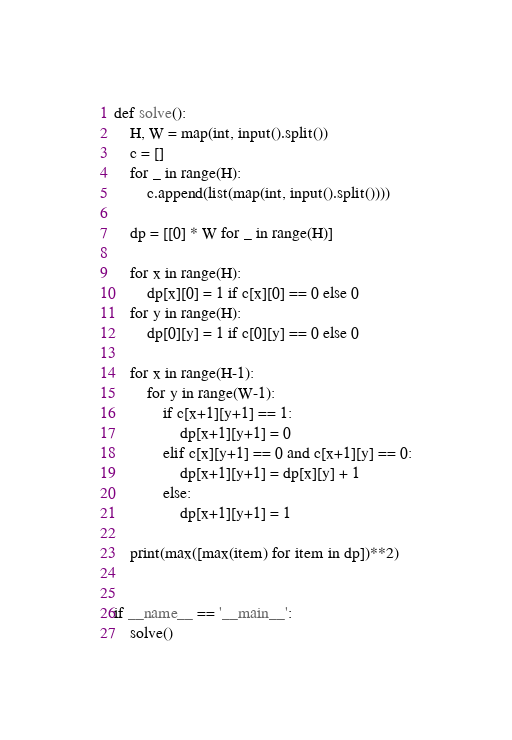<code> <loc_0><loc_0><loc_500><loc_500><_Python_>def solve():
    H, W = map(int, input().split())
    c = []
    for _ in range(H):
        c.append(list(map(int, input().split())))

    dp = [[0] * W for _ in range(H)]

    for x in range(H):
        dp[x][0] = 1 if c[x][0] == 0 else 0
    for y in range(H):
        dp[0][y] = 1 if c[0][y] == 0 else 0

    for x in range(H-1):
        for y in range(W-1):
            if c[x+1][y+1] == 1:
                dp[x+1][y+1] = 0
            elif c[x][y+1] == 0 and c[x+1][y] == 0:
                dp[x+1][y+1] = dp[x][y] + 1
            else:
                dp[x+1][y+1] = 1

    print(max([max(item) for item in dp])**2)


if __name__ == '__main__':
    solve()</code> 